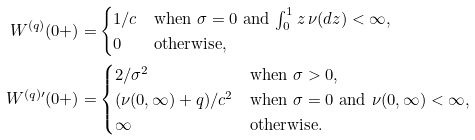Convert formula to latex. <formula><loc_0><loc_0><loc_500><loc_500>W ^ { ( q ) } ( 0 + ) = & \begin{cases} 1 / c & \text {when $\sigma=0$ and $\int_{0}^{1} z \, \nu(dz)<\infty$} , \\ 0 & \text {otherwise} , \end{cases} \\ W ^ { ( q ) \prime } ( 0 + ) = & \begin{cases} 2 / \sigma ^ { 2 } & \text {when $\sigma>0$,} \\ ( \nu ( 0 , \infty ) + q ) / c ^ { 2 } & \text {when $\sigma=0$ and $\nu(0,\infty)<\infty$,} \\ \infty & \text {otherwise.} \end{cases}</formula> 